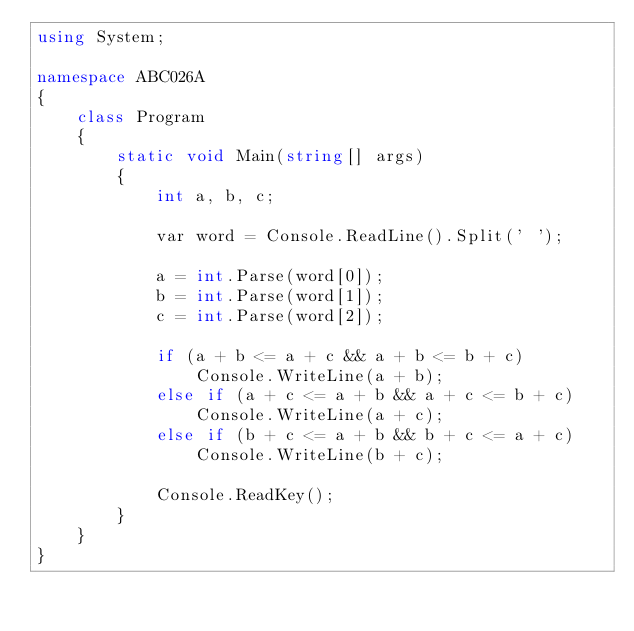Convert code to text. <code><loc_0><loc_0><loc_500><loc_500><_C#_>using System;

namespace ABC026A
{
    class Program
    {
        static void Main(string[] args)
        {
            int a, b, c;

            var word = Console.ReadLine().Split(' ');

            a = int.Parse(word[0]);
            b = int.Parse(word[1]);
            c = int.Parse(word[2]);

            if (a + b <= a + c && a + b <= b + c)
                Console.WriteLine(a + b);
            else if (a + c <= a + b && a + c <= b + c)
                Console.WriteLine(a + c);
            else if (b + c <= a + b && b + c <= a + c)
                Console.WriteLine(b + c);

            Console.ReadKey();
        }
    }
}
</code> 